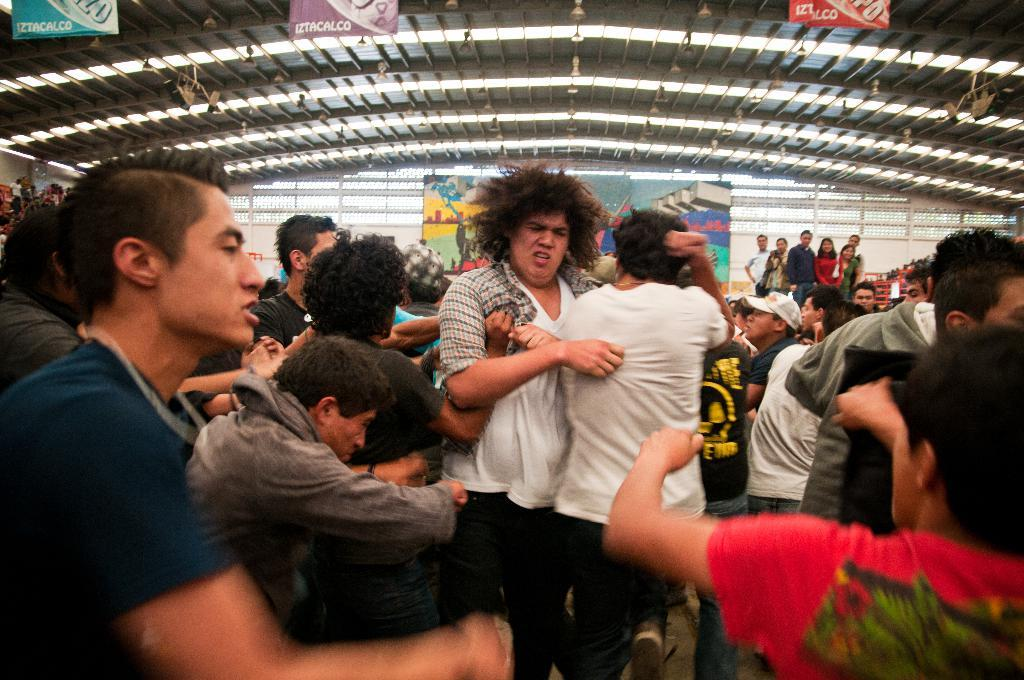How many people are present in the image? There are many people in the image. What can be seen at the top of the image? There are banners at the top of the image. What object is visible in the image? There is a board in the image. What type of illumination is present in the image? There are many lights in the image. What type of silk is being sold at the market in the image? There is: There is no market or silk present in the image. How many girls are visible in the image? There is no mention of girls in the provided facts, so we cannot determine their presence or number in the image. 